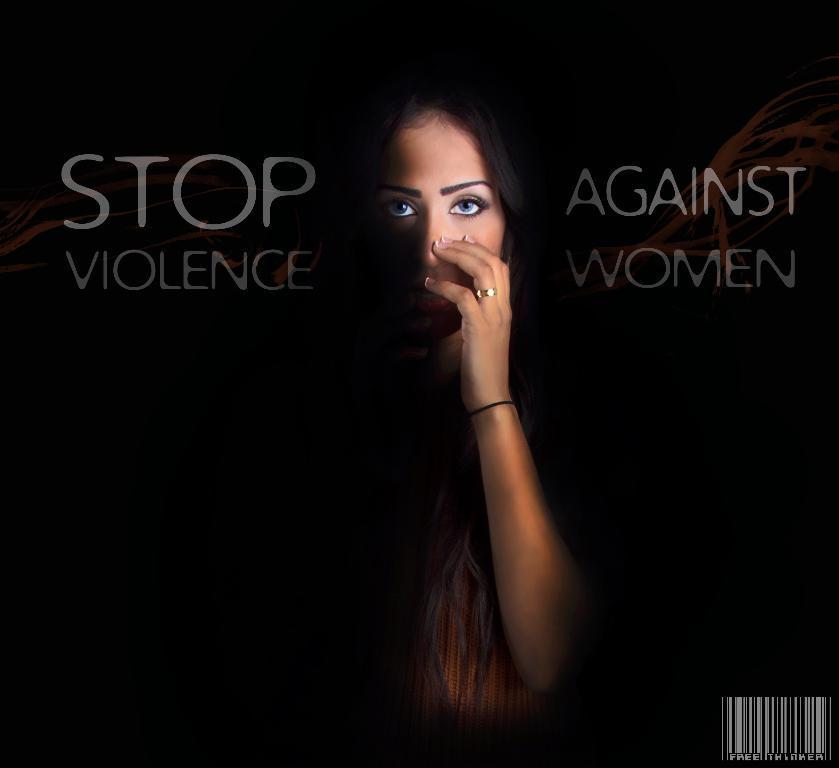In one or two sentences, can you explain what this image depicts? In the center of the image we can see one poster. On the poster, we can see one woman and some text. 